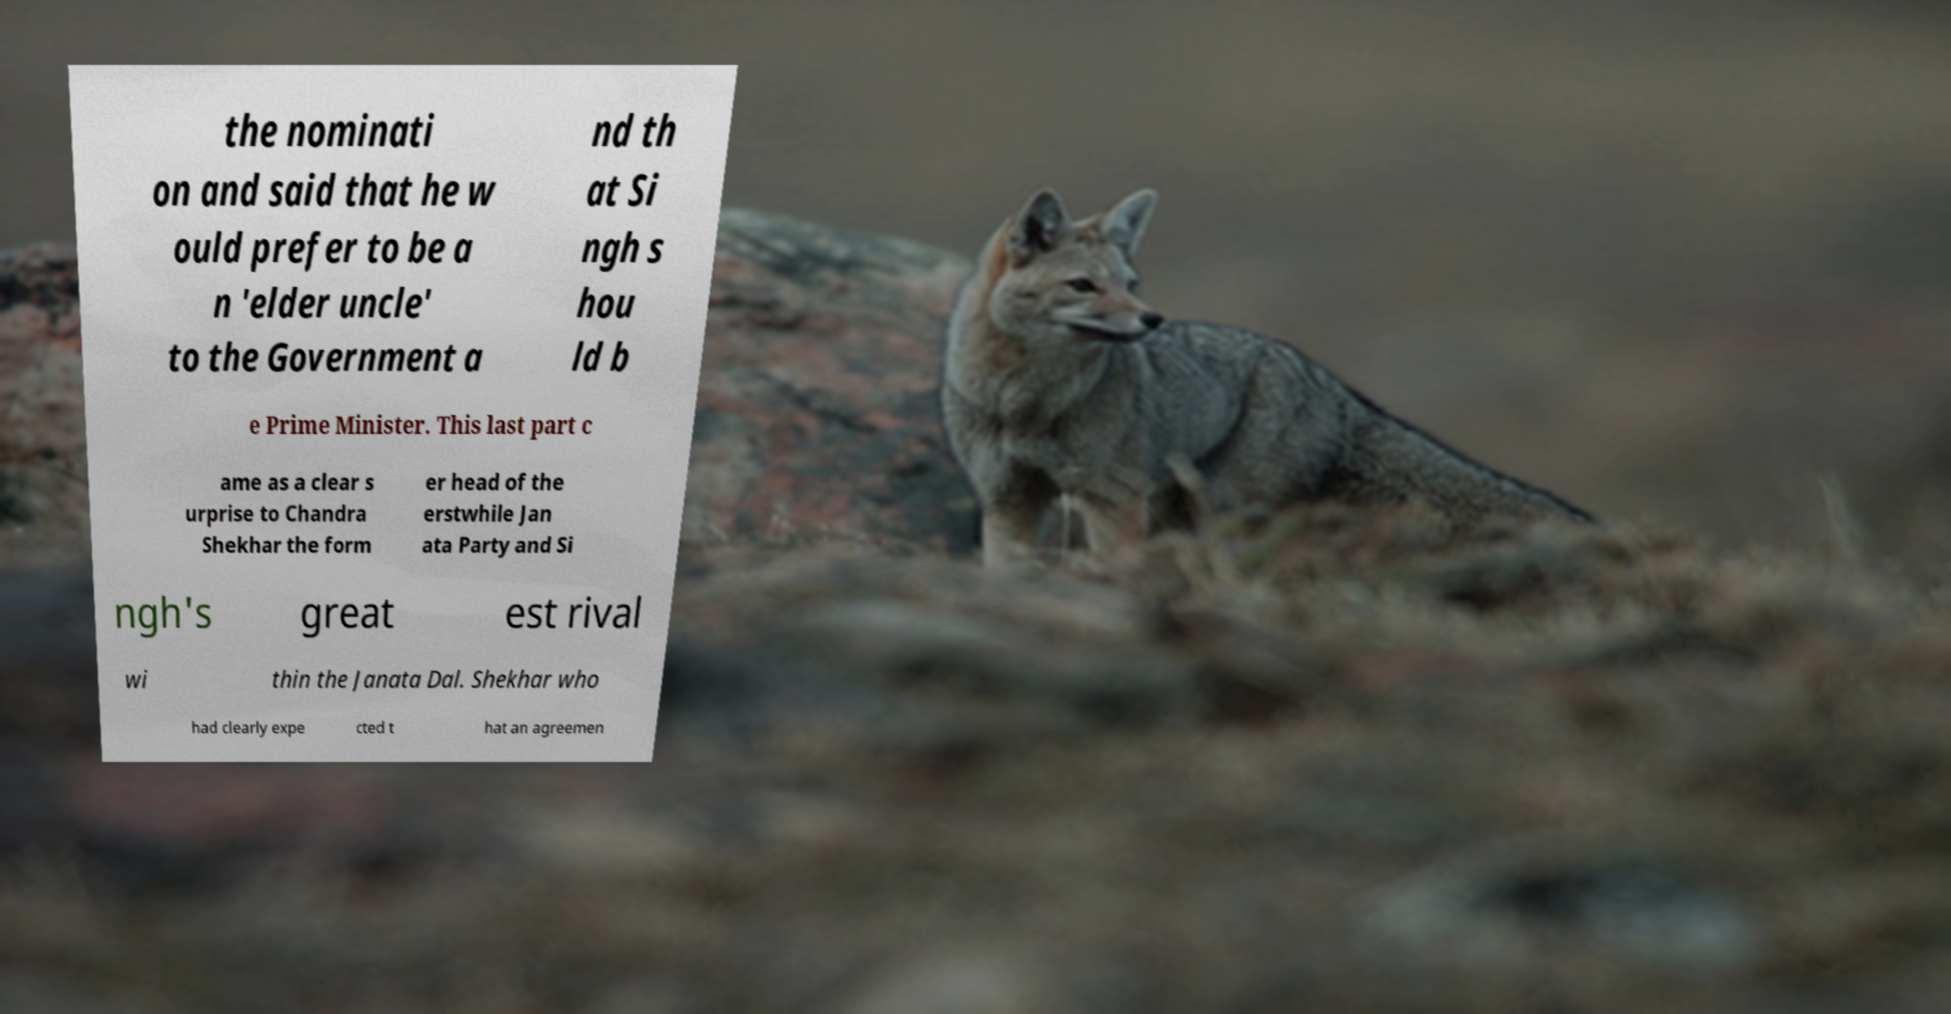Could you extract and type out the text from this image? the nominati on and said that he w ould prefer to be a n 'elder uncle' to the Government a nd th at Si ngh s hou ld b e Prime Minister. This last part c ame as a clear s urprise to Chandra Shekhar the form er head of the erstwhile Jan ata Party and Si ngh's great est rival wi thin the Janata Dal. Shekhar who had clearly expe cted t hat an agreemen 